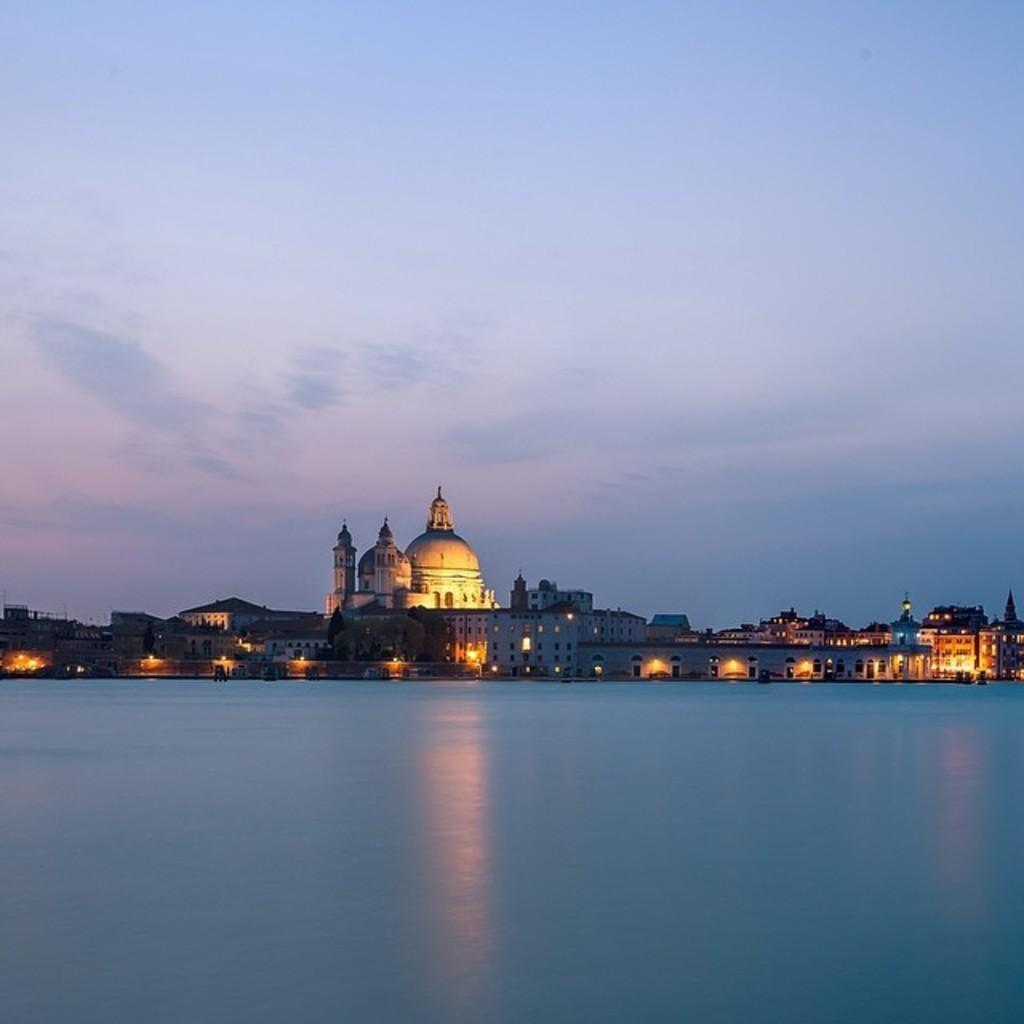What is the main feature in the middle of the picture? There is a river in the middle of the picture. What can be seen in the background of the picture? There are buildings and the sky visible in the background of the picture. Are there any ghosts visible in the image? There are no ghosts present in the image. Can you see any cobwebs hanging from the buildings in the image? There is no mention of cobwebs in the image, and they cannot be seen based on the provided facts. 